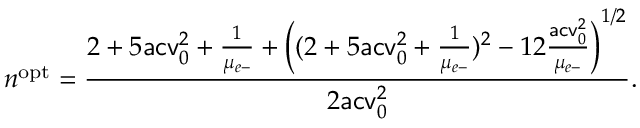Convert formula to latex. <formula><loc_0><loc_0><loc_500><loc_500>n ^ { o p t } = \frac { 2 + 5 a c v _ { 0 } ^ { 2 } + \frac { 1 } { \mu _ { e - } } + \left ( ( 2 + 5 a c v _ { 0 } ^ { 2 } + \frac { 1 } { \mu _ { e - } } ) ^ { 2 } - 1 2 \frac { a c v _ { 0 } ^ { 2 } } { \mu _ { e - } } \right ) ^ { 1 / 2 } } { 2 a c v _ { 0 } ^ { 2 } } .</formula> 